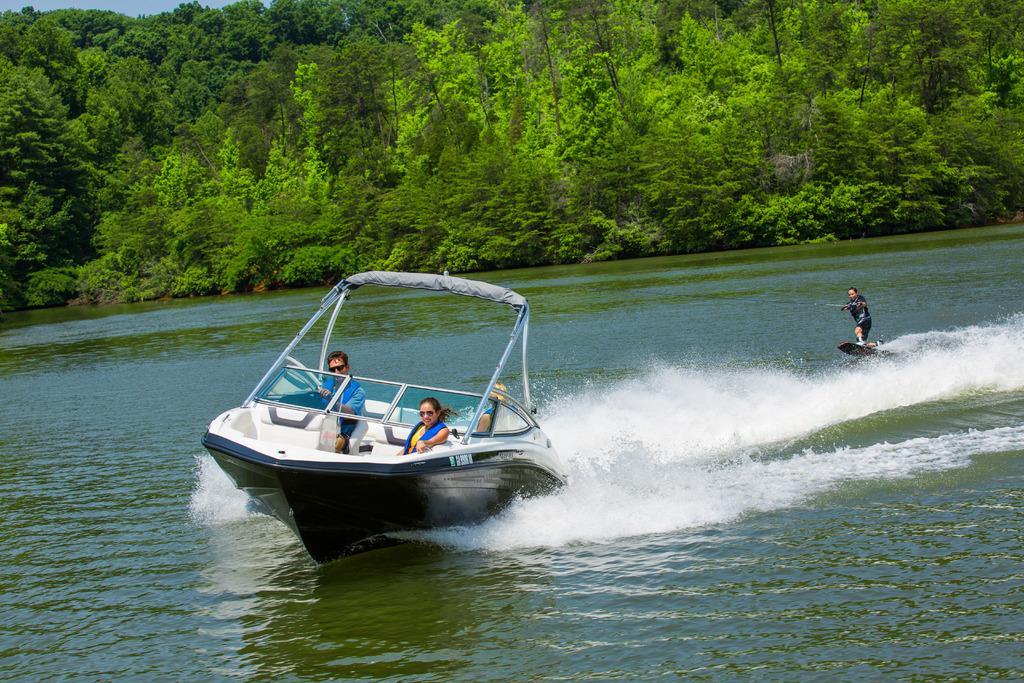In one or two sentences, can you explain what this image depicts? In this picture there is a small boat with man and woman sitting and driving the boat on the water. Behind we can see a man doing surfing board on the water. In the background there are some trees. 